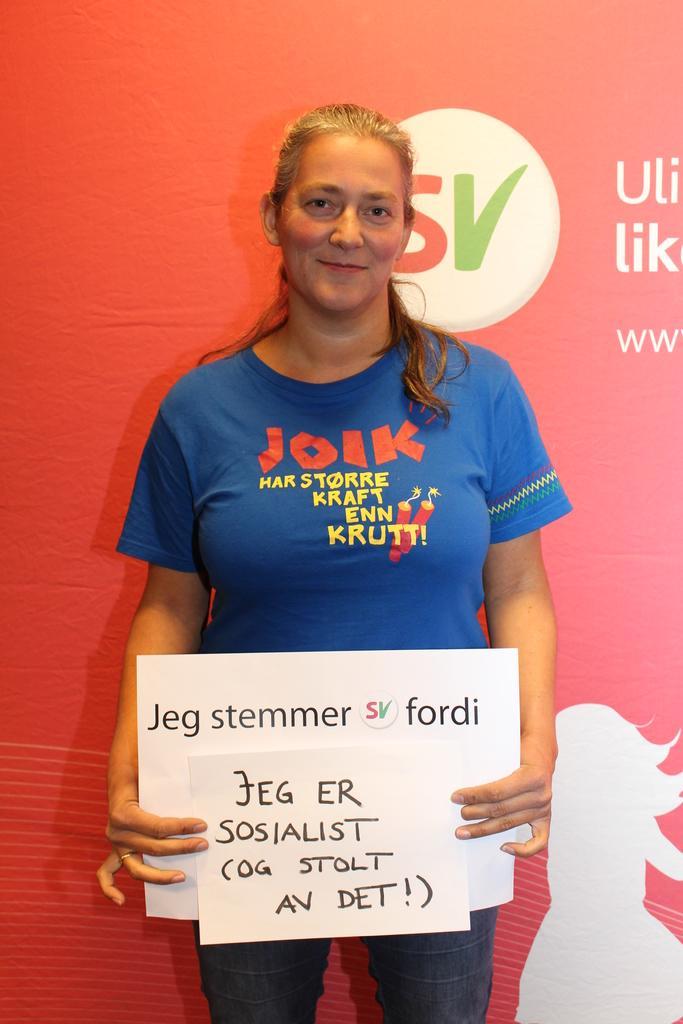How would you summarize this image in a sentence or two? In this image I can see a person standing wearing blue shirt holding a board which is in white color. Background I can see the other banner in red color. 